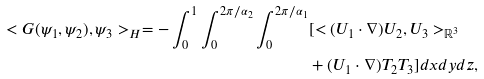Convert formula to latex. <formula><loc_0><loc_0><loc_500><loc_500>< G ( \psi _ { 1 } , \psi _ { 2 } ) , \psi _ { 3 } > _ { H } = - \int _ { 0 } ^ { 1 } \int _ { 0 } ^ { 2 \pi / \alpha _ { 2 } } \int _ { 0 } ^ { 2 \pi / \alpha _ { 1 } } & [ < ( U _ { 1 } \cdot \nabla ) U _ { 2 } , U _ { 3 } > _ { \mathbb { R } ^ { 3 } } \\ & + ( U _ { 1 } \cdot \nabla ) T _ { 2 } T _ { 3 } ] d x d y d z ,</formula> 